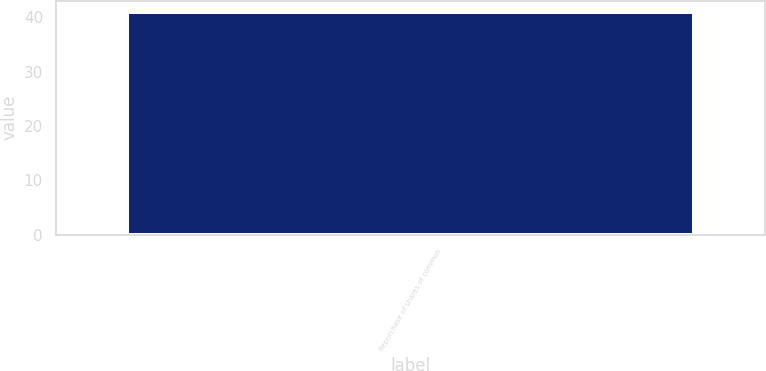Convert chart to OTSL. <chart><loc_0><loc_0><loc_500><loc_500><bar_chart><fcel>Repurchase of shares of common<nl><fcel>41<nl></chart> 